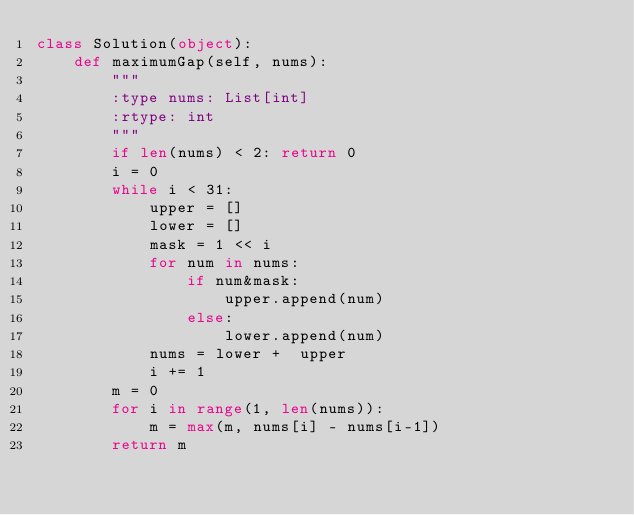Convert code to text. <code><loc_0><loc_0><loc_500><loc_500><_Python_>class Solution(object):    def maximumGap(self, nums):        """        :type nums: List[int]        :rtype: int        """        if len(nums) < 2: return 0        i = 0        while i < 31:            upper = []            lower = []            mask = 1 << i            for num in nums:                if num&mask:                    upper.append(num)                else:                    lower.append(num)            nums = lower +  upper            i += 1        m = 0        for i in range(1, len(nums)):            m = max(m, nums[i] - nums[i-1])        return m</code> 